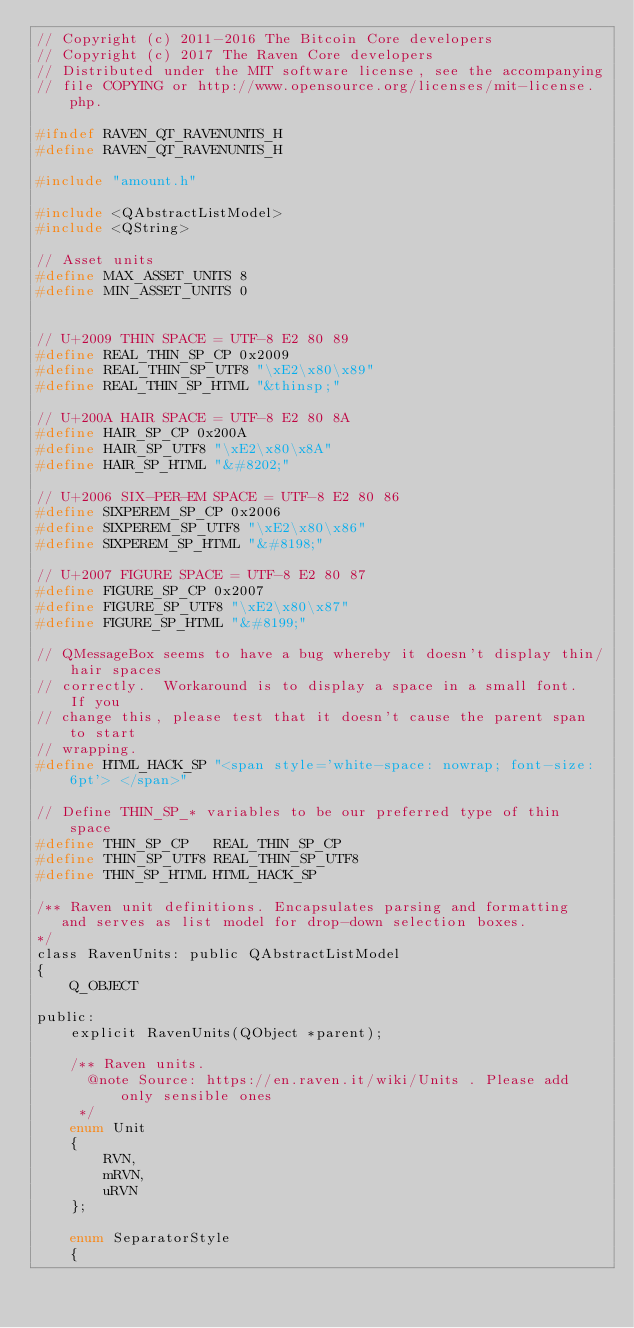Convert code to text. <code><loc_0><loc_0><loc_500><loc_500><_C_>// Copyright (c) 2011-2016 The Bitcoin Core developers
// Copyright (c) 2017 The Raven Core developers
// Distributed under the MIT software license, see the accompanying
// file COPYING or http://www.opensource.org/licenses/mit-license.php.

#ifndef RAVEN_QT_RAVENUNITS_H
#define RAVEN_QT_RAVENUNITS_H

#include "amount.h"

#include <QAbstractListModel>
#include <QString>

// Asset units
#define MAX_ASSET_UNITS 8
#define MIN_ASSET_UNITS 0


// U+2009 THIN SPACE = UTF-8 E2 80 89
#define REAL_THIN_SP_CP 0x2009
#define REAL_THIN_SP_UTF8 "\xE2\x80\x89"
#define REAL_THIN_SP_HTML "&thinsp;"

// U+200A HAIR SPACE = UTF-8 E2 80 8A
#define HAIR_SP_CP 0x200A
#define HAIR_SP_UTF8 "\xE2\x80\x8A"
#define HAIR_SP_HTML "&#8202;"

// U+2006 SIX-PER-EM SPACE = UTF-8 E2 80 86
#define SIXPEREM_SP_CP 0x2006
#define SIXPEREM_SP_UTF8 "\xE2\x80\x86"
#define SIXPEREM_SP_HTML "&#8198;"

// U+2007 FIGURE SPACE = UTF-8 E2 80 87
#define FIGURE_SP_CP 0x2007
#define FIGURE_SP_UTF8 "\xE2\x80\x87"
#define FIGURE_SP_HTML "&#8199;"

// QMessageBox seems to have a bug whereby it doesn't display thin/hair spaces
// correctly.  Workaround is to display a space in a small font.  If you
// change this, please test that it doesn't cause the parent span to start
// wrapping.
#define HTML_HACK_SP "<span style='white-space: nowrap; font-size: 6pt'> </span>"

// Define THIN_SP_* variables to be our preferred type of thin space
#define THIN_SP_CP   REAL_THIN_SP_CP
#define THIN_SP_UTF8 REAL_THIN_SP_UTF8
#define THIN_SP_HTML HTML_HACK_SP

/** Raven unit definitions. Encapsulates parsing and formatting
   and serves as list model for drop-down selection boxes.
*/
class RavenUnits: public QAbstractListModel
{
    Q_OBJECT

public:
    explicit RavenUnits(QObject *parent);

    /** Raven units.
      @note Source: https://en.raven.it/wiki/Units . Please add only sensible ones
     */
    enum Unit
    {
        RVN,
        mRVN,
        uRVN
    };

    enum SeparatorStyle
    {</code> 